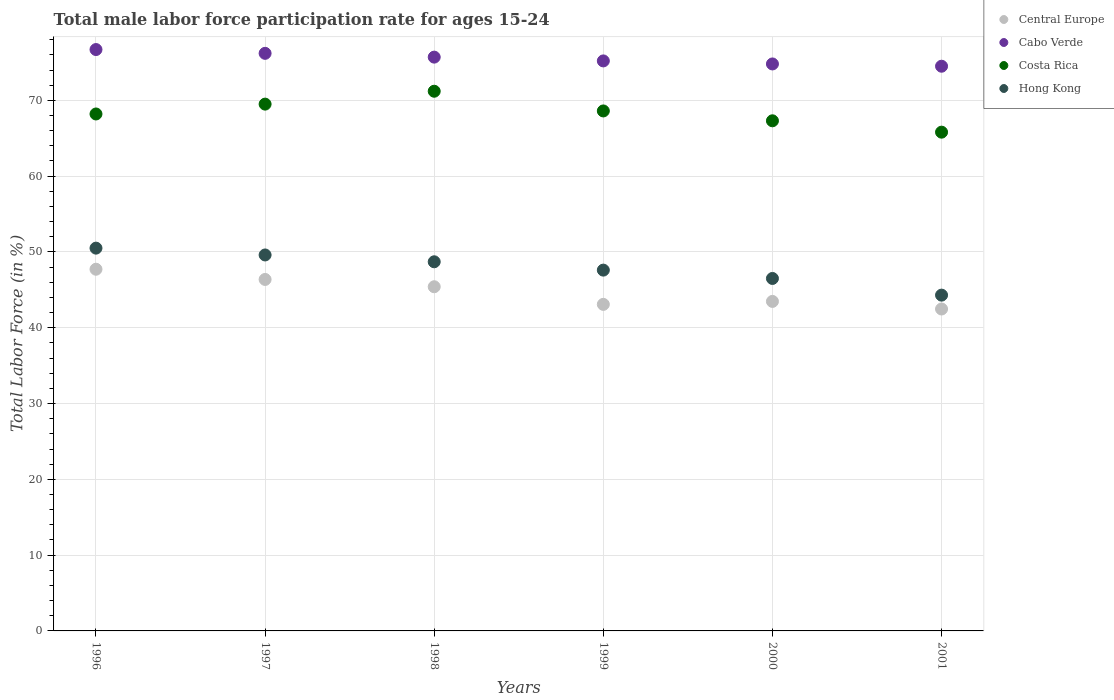Is the number of dotlines equal to the number of legend labels?
Provide a short and direct response. Yes. What is the male labor force participation rate in Central Europe in 2000?
Give a very brief answer. 43.47. Across all years, what is the maximum male labor force participation rate in Central Europe?
Keep it short and to the point. 47.72. Across all years, what is the minimum male labor force participation rate in Central Europe?
Keep it short and to the point. 42.47. In which year was the male labor force participation rate in Cabo Verde maximum?
Your answer should be compact. 1996. In which year was the male labor force participation rate in Central Europe minimum?
Your answer should be very brief. 2001. What is the total male labor force participation rate in Central Europe in the graph?
Your response must be concise. 268.52. What is the difference between the male labor force participation rate in Cabo Verde in 1997 and that in 2000?
Ensure brevity in your answer.  1.4. What is the average male labor force participation rate in Central Europe per year?
Your answer should be very brief. 44.75. In the year 1997, what is the difference between the male labor force participation rate in Central Europe and male labor force participation rate in Hong Kong?
Keep it short and to the point. -3.23. What is the ratio of the male labor force participation rate in Cabo Verde in 1998 to that in 2001?
Your answer should be very brief. 1.02. Is the male labor force participation rate in Central Europe in 2000 less than that in 2001?
Give a very brief answer. No. Is the difference between the male labor force participation rate in Central Europe in 1999 and 2000 greater than the difference between the male labor force participation rate in Hong Kong in 1999 and 2000?
Make the answer very short. No. What is the difference between the highest and the lowest male labor force participation rate in Central Europe?
Provide a short and direct response. 5.25. Is the sum of the male labor force participation rate in Central Europe in 1998 and 1999 greater than the maximum male labor force participation rate in Costa Rica across all years?
Your answer should be very brief. Yes. Is the male labor force participation rate in Cabo Verde strictly less than the male labor force participation rate in Costa Rica over the years?
Provide a short and direct response. No. How many dotlines are there?
Your answer should be very brief. 4. Does the graph contain any zero values?
Your response must be concise. No. How are the legend labels stacked?
Provide a short and direct response. Vertical. What is the title of the graph?
Give a very brief answer. Total male labor force participation rate for ages 15-24. What is the label or title of the X-axis?
Provide a succinct answer. Years. What is the Total Labor Force (in %) in Central Europe in 1996?
Your answer should be compact. 47.72. What is the Total Labor Force (in %) of Cabo Verde in 1996?
Provide a short and direct response. 76.7. What is the Total Labor Force (in %) of Costa Rica in 1996?
Your answer should be compact. 68.2. What is the Total Labor Force (in %) in Hong Kong in 1996?
Give a very brief answer. 50.5. What is the Total Labor Force (in %) of Central Europe in 1997?
Ensure brevity in your answer.  46.37. What is the Total Labor Force (in %) of Cabo Verde in 1997?
Your answer should be compact. 76.2. What is the Total Labor Force (in %) of Costa Rica in 1997?
Your response must be concise. 69.5. What is the Total Labor Force (in %) in Hong Kong in 1997?
Offer a very short reply. 49.6. What is the Total Labor Force (in %) in Central Europe in 1998?
Your answer should be very brief. 45.41. What is the Total Labor Force (in %) in Cabo Verde in 1998?
Provide a short and direct response. 75.7. What is the Total Labor Force (in %) in Costa Rica in 1998?
Keep it short and to the point. 71.2. What is the Total Labor Force (in %) of Hong Kong in 1998?
Your answer should be very brief. 48.7. What is the Total Labor Force (in %) of Central Europe in 1999?
Provide a short and direct response. 43.08. What is the Total Labor Force (in %) in Cabo Verde in 1999?
Keep it short and to the point. 75.2. What is the Total Labor Force (in %) of Costa Rica in 1999?
Your answer should be compact. 68.6. What is the Total Labor Force (in %) in Hong Kong in 1999?
Keep it short and to the point. 47.6. What is the Total Labor Force (in %) in Central Europe in 2000?
Offer a very short reply. 43.47. What is the Total Labor Force (in %) in Cabo Verde in 2000?
Your answer should be compact. 74.8. What is the Total Labor Force (in %) in Costa Rica in 2000?
Keep it short and to the point. 67.3. What is the Total Labor Force (in %) of Hong Kong in 2000?
Your answer should be compact. 46.5. What is the Total Labor Force (in %) of Central Europe in 2001?
Offer a very short reply. 42.47. What is the Total Labor Force (in %) in Cabo Verde in 2001?
Provide a short and direct response. 74.5. What is the Total Labor Force (in %) in Costa Rica in 2001?
Ensure brevity in your answer.  65.8. What is the Total Labor Force (in %) of Hong Kong in 2001?
Offer a terse response. 44.3. Across all years, what is the maximum Total Labor Force (in %) of Central Europe?
Offer a very short reply. 47.72. Across all years, what is the maximum Total Labor Force (in %) in Cabo Verde?
Make the answer very short. 76.7. Across all years, what is the maximum Total Labor Force (in %) in Costa Rica?
Keep it short and to the point. 71.2. Across all years, what is the maximum Total Labor Force (in %) of Hong Kong?
Provide a succinct answer. 50.5. Across all years, what is the minimum Total Labor Force (in %) in Central Europe?
Offer a very short reply. 42.47. Across all years, what is the minimum Total Labor Force (in %) of Cabo Verde?
Your answer should be very brief. 74.5. Across all years, what is the minimum Total Labor Force (in %) in Costa Rica?
Keep it short and to the point. 65.8. Across all years, what is the minimum Total Labor Force (in %) in Hong Kong?
Your answer should be compact. 44.3. What is the total Total Labor Force (in %) in Central Europe in the graph?
Your answer should be very brief. 268.52. What is the total Total Labor Force (in %) in Cabo Verde in the graph?
Give a very brief answer. 453.1. What is the total Total Labor Force (in %) in Costa Rica in the graph?
Make the answer very short. 410.6. What is the total Total Labor Force (in %) in Hong Kong in the graph?
Your answer should be compact. 287.2. What is the difference between the Total Labor Force (in %) in Central Europe in 1996 and that in 1997?
Your response must be concise. 1.35. What is the difference between the Total Labor Force (in %) of Cabo Verde in 1996 and that in 1997?
Give a very brief answer. 0.5. What is the difference between the Total Labor Force (in %) of Hong Kong in 1996 and that in 1997?
Provide a succinct answer. 0.9. What is the difference between the Total Labor Force (in %) in Central Europe in 1996 and that in 1998?
Your response must be concise. 2.31. What is the difference between the Total Labor Force (in %) of Costa Rica in 1996 and that in 1998?
Your response must be concise. -3. What is the difference between the Total Labor Force (in %) in Hong Kong in 1996 and that in 1998?
Your answer should be compact. 1.8. What is the difference between the Total Labor Force (in %) in Central Europe in 1996 and that in 1999?
Give a very brief answer. 4.64. What is the difference between the Total Labor Force (in %) of Cabo Verde in 1996 and that in 1999?
Make the answer very short. 1.5. What is the difference between the Total Labor Force (in %) in Costa Rica in 1996 and that in 1999?
Keep it short and to the point. -0.4. What is the difference between the Total Labor Force (in %) in Central Europe in 1996 and that in 2000?
Your answer should be very brief. 4.25. What is the difference between the Total Labor Force (in %) in Costa Rica in 1996 and that in 2000?
Offer a very short reply. 0.9. What is the difference between the Total Labor Force (in %) in Central Europe in 1996 and that in 2001?
Your answer should be compact. 5.25. What is the difference between the Total Labor Force (in %) of Cabo Verde in 1996 and that in 2001?
Provide a succinct answer. 2.2. What is the difference between the Total Labor Force (in %) in Hong Kong in 1996 and that in 2001?
Provide a succinct answer. 6.2. What is the difference between the Total Labor Force (in %) in Central Europe in 1997 and that in 1998?
Your response must be concise. 0.96. What is the difference between the Total Labor Force (in %) in Costa Rica in 1997 and that in 1998?
Ensure brevity in your answer.  -1.7. What is the difference between the Total Labor Force (in %) in Central Europe in 1997 and that in 1999?
Keep it short and to the point. 3.29. What is the difference between the Total Labor Force (in %) of Costa Rica in 1997 and that in 1999?
Ensure brevity in your answer.  0.9. What is the difference between the Total Labor Force (in %) of Central Europe in 1997 and that in 2000?
Ensure brevity in your answer.  2.9. What is the difference between the Total Labor Force (in %) of Central Europe in 1997 and that in 2001?
Keep it short and to the point. 3.9. What is the difference between the Total Labor Force (in %) in Cabo Verde in 1997 and that in 2001?
Provide a short and direct response. 1.7. What is the difference between the Total Labor Force (in %) of Costa Rica in 1997 and that in 2001?
Your response must be concise. 3.7. What is the difference between the Total Labor Force (in %) in Central Europe in 1998 and that in 1999?
Make the answer very short. 2.32. What is the difference between the Total Labor Force (in %) of Cabo Verde in 1998 and that in 1999?
Offer a terse response. 0.5. What is the difference between the Total Labor Force (in %) of Hong Kong in 1998 and that in 1999?
Your response must be concise. 1.1. What is the difference between the Total Labor Force (in %) of Central Europe in 1998 and that in 2000?
Offer a very short reply. 1.93. What is the difference between the Total Labor Force (in %) in Cabo Verde in 1998 and that in 2000?
Provide a succinct answer. 0.9. What is the difference between the Total Labor Force (in %) in Costa Rica in 1998 and that in 2000?
Ensure brevity in your answer.  3.9. What is the difference between the Total Labor Force (in %) of Hong Kong in 1998 and that in 2000?
Give a very brief answer. 2.2. What is the difference between the Total Labor Force (in %) of Central Europe in 1998 and that in 2001?
Offer a very short reply. 2.94. What is the difference between the Total Labor Force (in %) in Costa Rica in 1998 and that in 2001?
Your answer should be very brief. 5.4. What is the difference between the Total Labor Force (in %) in Central Europe in 1999 and that in 2000?
Offer a very short reply. -0.39. What is the difference between the Total Labor Force (in %) of Central Europe in 1999 and that in 2001?
Keep it short and to the point. 0.61. What is the difference between the Total Labor Force (in %) of Cabo Verde in 1999 and that in 2001?
Keep it short and to the point. 0.7. What is the difference between the Total Labor Force (in %) in Costa Rica in 1999 and that in 2001?
Ensure brevity in your answer.  2.8. What is the difference between the Total Labor Force (in %) in Central Europe in 2000 and that in 2001?
Keep it short and to the point. 1. What is the difference between the Total Labor Force (in %) in Cabo Verde in 2000 and that in 2001?
Offer a terse response. 0.3. What is the difference between the Total Labor Force (in %) in Hong Kong in 2000 and that in 2001?
Your answer should be very brief. 2.2. What is the difference between the Total Labor Force (in %) in Central Europe in 1996 and the Total Labor Force (in %) in Cabo Verde in 1997?
Your answer should be very brief. -28.48. What is the difference between the Total Labor Force (in %) in Central Europe in 1996 and the Total Labor Force (in %) in Costa Rica in 1997?
Your answer should be compact. -21.78. What is the difference between the Total Labor Force (in %) of Central Europe in 1996 and the Total Labor Force (in %) of Hong Kong in 1997?
Provide a short and direct response. -1.88. What is the difference between the Total Labor Force (in %) of Cabo Verde in 1996 and the Total Labor Force (in %) of Hong Kong in 1997?
Offer a terse response. 27.1. What is the difference between the Total Labor Force (in %) of Central Europe in 1996 and the Total Labor Force (in %) of Cabo Verde in 1998?
Your answer should be compact. -27.98. What is the difference between the Total Labor Force (in %) in Central Europe in 1996 and the Total Labor Force (in %) in Costa Rica in 1998?
Offer a very short reply. -23.48. What is the difference between the Total Labor Force (in %) of Central Europe in 1996 and the Total Labor Force (in %) of Hong Kong in 1998?
Provide a short and direct response. -0.98. What is the difference between the Total Labor Force (in %) of Cabo Verde in 1996 and the Total Labor Force (in %) of Costa Rica in 1998?
Your answer should be very brief. 5.5. What is the difference between the Total Labor Force (in %) of Cabo Verde in 1996 and the Total Labor Force (in %) of Hong Kong in 1998?
Keep it short and to the point. 28. What is the difference between the Total Labor Force (in %) of Costa Rica in 1996 and the Total Labor Force (in %) of Hong Kong in 1998?
Keep it short and to the point. 19.5. What is the difference between the Total Labor Force (in %) of Central Europe in 1996 and the Total Labor Force (in %) of Cabo Verde in 1999?
Make the answer very short. -27.48. What is the difference between the Total Labor Force (in %) of Central Europe in 1996 and the Total Labor Force (in %) of Costa Rica in 1999?
Your answer should be very brief. -20.88. What is the difference between the Total Labor Force (in %) of Central Europe in 1996 and the Total Labor Force (in %) of Hong Kong in 1999?
Offer a terse response. 0.12. What is the difference between the Total Labor Force (in %) of Cabo Verde in 1996 and the Total Labor Force (in %) of Hong Kong in 1999?
Ensure brevity in your answer.  29.1. What is the difference between the Total Labor Force (in %) in Costa Rica in 1996 and the Total Labor Force (in %) in Hong Kong in 1999?
Your answer should be compact. 20.6. What is the difference between the Total Labor Force (in %) of Central Europe in 1996 and the Total Labor Force (in %) of Cabo Verde in 2000?
Provide a succinct answer. -27.08. What is the difference between the Total Labor Force (in %) in Central Europe in 1996 and the Total Labor Force (in %) in Costa Rica in 2000?
Keep it short and to the point. -19.58. What is the difference between the Total Labor Force (in %) of Central Europe in 1996 and the Total Labor Force (in %) of Hong Kong in 2000?
Offer a very short reply. 1.22. What is the difference between the Total Labor Force (in %) in Cabo Verde in 1996 and the Total Labor Force (in %) in Costa Rica in 2000?
Give a very brief answer. 9.4. What is the difference between the Total Labor Force (in %) in Cabo Verde in 1996 and the Total Labor Force (in %) in Hong Kong in 2000?
Offer a terse response. 30.2. What is the difference between the Total Labor Force (in %) in Costa Rica in 1996 and the Total Labor Force (in %) in Hong Kong in 2000?
Make the answer very short. 21.7. What is the difference between the Total Labor Force (in %) in Central Europe in 1996 and the Total Labor Force (in %) in Cabo Verde in 2001?
Your answer should be compact. -26.78. What is the difference between the Total Labor Force (in %) in Central Europe in 1996 and the Total Labor Force (in %) in Costa Rica in 2001?
Keep it short and to the point. -18.08. What is the difference between the Total Labor Force (in %) in Central Europe in 1996 and the Total Labor Force (in %) in Hong Kong in 2001?
Provide a short and direct response. 3.42. What is the difference between the Total Labor Force (in %) in Cabo Verde in 1996 and the Total Labor Force (in %) in Hong Kong in 2001?
Provide a short and direct response. 32.4. What is the difference between the Total Labor Force (in %) of Costa Rica in 1996 and the Total Labor Force (in %) of Hong Kong in 2001?
Your response must be concise. 23.9. What is the difference between the Total Labor Force (in %) in Central Europe in 1997 and the Total Labor Force (in %) in Cabo Verde in 1998?
Offer a terse response. -29.33. What is the difference between the Total Labor Force (in %) in Central Europe in 1997 and the Total Labor Force (in %) in Costa Rica in 1998?
Keep it short and to the point. -24.83. What is the difference between the Total Labor Force (in %) of Central Europe in 1997 and the Total Labor Force (in %) of Hong Kong in 1998?
Offer a very short reply. -2.33. What is the difference between the Total Labor Force (in %) of Cabo Verde in 1997 and the Total Labor Force (in %) of Costa Rica in 1998?
Offer a terse response. 5. What is the difference between the Total Labor Force (in %) in Costa Rica in 1997 and the Total Labor Force (in %) in Hong Kong in 1998?
Your answer should be compact. 20.8. What is the difference between the Total Labor Force (in %) of Central Europe in 1997 and the Total Labor Force (in %) of Cabo Verde in 1999?
Give a very brief answer. -28.83. What is the difference between the Total Labor Force (in %) in Central Europe in 1997 and the Total Labor Force (in %) in Costa Rica in 1999?
Your response must be concise. -22.23. What is the difference between the Total Labor Force (in %) of Central Europe in 1997 and the Total Labor Force (in %) of Hong Kong in 1999?
Offer a terse response. -1.23. What is the difference between the Total Labor Force (in %) in Cabo Verde in 1997 and the Total Labor Force (in %) in Costa Rica in 1999?
Make the answer very short. 7.6. What is the difference between the Total Labor Force (in %) in Cabo Verde in 1997 and the Total Labor Force (in %) in Hong Kong in 1999?
Offer a terse response. 28.6. What is the difference between the Total Labor Force (in %) of Costa Rica in 1997 and the Total Labor Force (in %) of Hong Kong in 1999?
Give a very brief answer. 21.9. What is the difference between the Total Labor Force (in %) in Central Europe in 1997 and the Total Labor Force (in %) in Cabo Verde in 2000?
Provide a short and direct response. -28.43. What is the difference between the Total Labor Force (in %) in Central Europe in 1997 and the Total Labor Force (in %) in Costa Rica in 2000?
Provide a short and direct response. -20.93. What is the difference between the Total Labor Force (in %) of Central Europe in 1997 and the Total Labor Force (in %) of Hong Kong in 2000?
Provide a short and direct response. -0.13. What is the difference between the Total Labor Force (in %) of Cabo Verde in 1997 and the Total Labor Force (in %) of Costa Rica in 2000?
Ensure brevity in your answer.  8.9. What is the difference between the Total Labor Force (in %) in Cabo Verde in 1997 and the Total Labor Force (in %) in Hong Kong in 2000?
Your answer should be very brief. 29.7. What is the difference between the Total Labor Force (in %) of Costa Rica in 1997 and the Total Labor Force (in %) of Hong Kong in 2000?
Offer a very short reply. 23. What is the difference between the Total Labor Force (in %) of Central Europe in 1997 and the Total Labor Force (in %) of Cabo Verde in 2001?
Ensure brevity in your answer.  -28.13. What is the difference between the Total Labor Force (in %) in Central Europe in 1997 and the Total Labor Force (in %) in Costa Rica in 2001?
Provide a short and direct response. -19.43. What is the difference between the Total Labor Force (in %) of Central Europe in 1997 and the Total Labor Force (in %) of Hong Kong in 2001?
Keep it short and to the point. 2.07. What is the difference between the Total Labor Force (in %) of Cabo Verde in 1997 and the Total Labor Force (in %) of Hong Kong in 2001?
Your answer should be compact. 31.9. What is the difference between the Total Labor Force (in %) of Costa Rica in 1997 and the Total Labor Force (in %) of Hong Kong in 2001?
Provide a short and direct response. 25.2. What is the difference between the Total Labor Force (in %) of Central Europe in 1998 and the Total Labor Force (in %) of Cabo Verde in 1999?
Your answer should be compact. -29.79. What is the difference between the Total Labor Force (in %) of Central Europe in 1998 and the Total Labor Force (in %) of Costa Rica in 1999?
Offer a terse response. -23.19. What is the difference between the Total Labor Force (in %) of Central Europe in 1998 and the Total Labor Force (in %) of Hong Kong in 1999?
Your response must be concise. -2.19. What is the difference between the Total Labor Force (in %) in Cabo Verde in 1998 and the Total Labor Force (in %) in Costa Rica in 1999?
Provide a short and direct response. 7.1. What is the difference between the Total Labor Force (in %) in Cabo Verde in 1998 and the Total Labor Force (in %) in Hong Kong in 1999?
Your answer should be compact. 28.1. What is the difference between the Total Labor Force (in %) of Costa Rica in 1998 and the Total Labor Force (in %) of Hong Kong in 1999?
Ensure brevity in your answer.  23.6. What is the difference between the Total Labor Force (in %) of Central Europe in 1998 and the Total Labor Force (in %) of Cabo Verde in 2000?
Give a very brief answer. -29.39. What is the difference between the Total Labor Force (in %) of Central Europe in 1998 and the Total Labor Force (in %) of Costa Rica in 2000?
Offer a very short reply. -21.89. What is the difference between the Total Labor Force (in %) in Central Europe in 1998 and the Total Labor Force (in %) in Hong Kong in 2000?
Your answer should be compact. -1.09. What is the difference between the Total Labor Force (in %) in Cabo Verde in 1998 and the Total Labor Force (in %) in Hong Kong in 2000?
Give a very brief answer. 29.2. What is the difference between the Total Labor Force (in %) in Costa Rica in 1998 and the Total Labor Force (in %) in Hong Kong in 2000?
Offer a very short reply. 24.7. What is the difference between the Total Labor Force (in %) in Central Europe in 1998 and the Total Labor Force (in %) in Cabo Verde in 2001?
Give a very brief answer. -29.09. What is the difference between the Total Labor Force (in %) in Central Europe in 1998 and the Total Labor Force (in %) in Costa Rica in 2001?
Give a very brief answer. -20.39. What is the difference between the Total Labor Force (in %) in Central Europe in 1998 and the Total Labor Force (in %) in Hong Kong in 2001?
Your answer should be very brief. 1.11. What is the difference between the Total Labor Force (in %) in Cabo Verde in 1998 and the Total Labor Force (in %) in Hong Kong in 2001?
Make the answer very short. 31.4. What is the difference between the Total Labor Force (in %) of Costa Rica in 1998 and the Total Labor Force (in %) of Hong Kong in 2001?
Ensure brevity in your answer.  26.9. What is the difference between the Total Labor Force (in %) of Central Europe in 1999 and the Total Labor Force (in %) of Cabo Verde in 2000?
Offer a terse response. -31.72. What is the difference between the Total Labor Force (in %) in Central Europe in 1999 and the Total Labor Force (in %) in Costa Rica in 2000?
Provide a short and direct response. -24.22. What is the difference between the Total Labor Force (in %) in Central Europe in 1999 and the Total Labor Force (in %) in Hong Kong in 2000?
Ensure brevity in your answer.  -3.42. What is the difference between the Total Labor Force (in %) of Cabo Verde in 1999 and the Total Labor Force (in %) of Hong Kong in 2000?
Make the answer very short. 28.7. What is the difference between the Total Labor Force (in %) in Costa Rica in 1999 and the Total Labor Force (in %) in Hong Kong in 2000?
Keep it short and to the point. 22.1. What is the difference between the Total Labor Force (in %) of Central Europe in 1999 and the Total Labor Force (in %) of Cabo Verde in 2001?
Offer a very short reply. -31.42. What is the difference between the Total Labor Force (in %) of Central Europe in 1999 and the Total Labor Force (in %) of Costa Rica in 2001?
Provide a succinct answer. -22.72. What is the difference between the Total Labor Force (in %) of Central Europe in 1999 and the Total Labor Force (in %) of Hong Kong in 2001?
Offer a very short reply. -1.22. What is the difference between the Total Labor Force (in %) of Cabo Verde in 1999 and the Total Labor Force (in %) of Costa Rica in 2001?
Your answer should be compact. 9.4. What is the difference between the Total Labor Force (in %) of Cabo Verde in 1999 and the Total Labor Force (in %) of Hong Kong in 2001?
Keep it short and to the point. 30.9. What is the difference between the Total Labor Force (in %) of Costa Rica in 1999 and the Total Labor Force (in %) of Hong Kong in 2001?
Your answer should be compact. 24.3. What is the difference between the Total Labor Force (in %) in Central Europe in 2000 and the Total Labor Force (in %) in Cabo Verde in 2001?
Offer a terse response. -31.03. What is the difference between the Total Labor Force (in %) of Central Europe in 2000 and the Total Labor Force (in %) of Costa Rica in 2001?
Keep it short and to the point. -22.33. What is the difference between the Total Labor Force (in %) of Central Europe in 2000 and the Total Labor Force (in %) of Hong Kong in 2001?
Offer a terse response. -0.83. What is the difference between the Total Labor Force (in %) of Cabo Verde in 2000 and the Total Labor Force (in %) of Hong Kong in 2001?
Make the answer very short. 30.5. What is the difference between the Total Labor Force (in %) in Costa Rica in 2000 and the Total Labor Force (in %) in Hong Kong in 2001?
Provide a succinct answer. 23. What is the average Total Labor Force (in %) of Central Europe per year?
Provide a succinct answer. 44.75. What is the average Total Labor Force (in %) in Cabo Verde per year?
Give a very brief answer. 75.52. What is the average Total Labor Force (in %) of Costa Rica per year?
Keep it short and to the point. 68.43. What is the average Total Labor Force (in %) of Hong Kong per year?
Offer a very short reply. 47.87. In the year 1996, what is the difference between the Total Labor Force (in %) of Central Europe and Total Labor Force (in %) of Cabo Verde?
Ensure brevity in your answer.  -28.98. In the year 1996, what is the difference between the Total Labor Force (in %) in Central Europe and Total Labor Force (in %) in Costa Rica?
Ensure brevity in your answer.  -20.48. In the year 1996, what is the difference between the Total Labor Force (in %) of Central Europe and Total Labor Force (in %) of Hong Kong?
Your answer should be very brief. -2.78. In the year 1996, what is the difference between the Total Labor Force (in %) of Cabo Verde and Total Labor Force (in %) of Costa Rica?
Provide a short and direct response. 8.5. In the year 1996, what is the difference between the Total Labor Force (in %) of Cabo Verde and Total Labor Force (in %) of Hong Kong?
Keep it short and to the point. 26.2. In the year 1996, what is the difference between the Total Labor Force (in %) in Costa Rica and Total Labor Force (in %) in Hong Kong?
Provide a succinct answer. 17.7. In the year 1997, what is the difference between the Total Labor Force (in %) of Central Europe and Total Labor Force (in %) of Cabo Verde?
Make the answer very short. -29.83. In the year 1997, what is the difference between the Total Labor Force (in %) in Central Europe and Total Labor Force (in %) in Costa Rica?
Ensure brevity in your answer.  -23.13. In the year 1997, what is the difference between the Total Labor Force (in %) in Central Europe and Total Labor Force (in %) in Hong Kong?
Your answer should be very brief. -3.23. In the year 1997, what is the difference between the Total Labor Force (in %) of Cabo Verde and Total Labor Force (in %) of Hong Kong?
Your answer should be very brief. 26.6. In the year 1998, what is the difference between the Total Labor Force (in %) of Central Europe and Total Labor Force (in %) of Cabo Verde?
Keep it short and to the point. -30.29. In the year 1998, what is the difference between the Total Labor Force (in %) in Central Europe and Total Labor Force (in %) in Costa Rica?
Keep it short and to the point. -25.79. In the year 1998, what is the difference between the Total Labor Force (in %) in Central Europe and Total Labor Force (in %) in Hong Kong?
Ensure brevity in your answer.  -3.29. In the year 1998, what is the difference between the Total Labor Force (in %) of Cabo Verde and Total Labor Force (in %) of Costa Rica?
Provide a short and direct response. 4.5. In the year 1998, what is the difference between the Total Labor Force (in %) in Cabo Verde and Total Labor Force (in %) in Hong Kong?
Your response must be concise. 27. In the year 1998, what is the difference between the Total Labor Force (in %) of Costa Rica and Total Labor Force (in %) of Hong Kong?
Your answer should be very brief. 22.5. In the year 1999, what is the difference between the Total Labor Force (in %) in Central Europe and Total Labor Force (in %) in Cabo Verde?
Offer a very short reply. -32.12. In the year 1999, what is the difference between the Total Labor Force (in %) of Central Europe and Total Labor Force (in %) of Costa Rica?
Your answer should be compact. -25.52. In the year 1999, what is the difference between the Total Labor Force (in %) in Central Europe and Total Labor Force (in %) in Hong Kong?
Offer a terse response. -4.52. In the year 1999, what is the difference between the Total Labor Force (in %) in Cabo Verde and Total Labor Force (in %) in Hong Kong?
Ensure brevity in your answer.  27.6. In the year 1999, what is the difference between the Total Labor Force (in %) in Costa Rica and Total Labor Force (in %) in Hong Kong?
Your answer should be compact. 21. In the year 2000, what is the difference between the Total Labor Force (in %) of Central Europe and Total Labor Force (in %) of Cabo Verde?
Give a very brief answer. -31.33. In the year 2000, what is the difference between the Total Labor Force (in %) in Central Europe and Total Labor Force (in %) in Costa Rica?
Provide a short and direct response. -23.83. In the year 2000, what is the difference between the Total Labor Force (in %) of Central Europe and Total Labor Force (in %) of Hong Kong?
Ensure brevity in your answer.  -3.03. In the year 2000, what is the difference between the Total Labor Force (in %) of Cabo Verde and Total Labor Force (in %) of Costa Rica?
Your answer should be very brief. 7.5. In the year 2000, what is the difference between the Total Labor Force (in %) of Cabo Verde and Total Labor Force (in %) of Hong Kong?
Your response must be concise. 28.3. In the year 2000, what is the difference between the Total Labor Force (in %) of Costa Rica and Total Labor Force (in %) of Hong Kong?
Your answer should be compact. 20.8. In the year 2001, what is the difference between the Total Labor Force (in %) in Central Europe and Total Labor Force (in %) in Cabo Verde?
Keep it short and to the point. -32.03. In the year 2001, what is the difference between the Total Labor Force (in %) of Central Europe and Total Labor Force (in %) of Costa Rica?
Provide a short and direct response. -23.33. In the year 2001, what is the difference between the Total Labor Force (in %) in Central Europe and Total Labor Force (in %) in Hong Kong?
Make the answer very short. -1.83. In the year 2001, what is the difference between the Total Labor Force (in %) of Cabo Verde and Total Labor Force (in %) of Hong Kong?
Make the answer very short. 30.2. In the year 2001, what is the difference between the Total Labor Force (in %) of Costa Rica and Total Labor Force (in %) of Hong Kong?
Your answer should be very brief. 21.5. What is the ratio of the Total Labor Force (in %) of Central Europe in 1996 to that in 1997?
Give a very brief answer. 1.03. What is the ratio of the Total Labor Force (in %) of Cabo Verde in 1996 to that in 1997?
Give a very brief answer. 1.01. What is the ratio of the Total Labor Force (in %) of Costa Rica in 1996 to that in 1997?
Your answer should be very brief. 0.98. What is the ratio of the Total Labor Force (in %) in Hong Kong in 1996 to that in 1997?
Provide a short and direct response. 1.02. What is the ratio of the Total Labor Force (in %) in Central Europe in 1996 to that in 1998?
Offer a terse response. 1.05. What is the ratio of the Total Labor Force (in %) in Cabo Verde in 1996 to that in 1998?
Give a very brief answer. 1.01. What is the ratio of the Total Labor Force (in %) in Costa Rica in 1996 to that in 1998?
Your answer should be compact. 0.96. What is the ratio of the Total Labor Force (in %) in Central Europe in 1996 to that in 1999?
Offer a very short reply. 1.11. What is the ratio of the Total Labor Force (in %) of Cabo Verde in 1996 to that in 1999?
Offer a terse response. 1.02. What is the ratio of the Total Labor Force (in %) of Costa Rica in 1996 to that in 1999?
Your response must be concise. 0.99. What is the ratio of the Total Labor Force (in %) of Hong Kong in 1996 to that in 1999?
Provide a short and direct response. 1.06. What is the ratio of the Total Labor Force (in %) of Central Europe in 1996 to that in 2000?
Your answer should be compact. 1.1. What is the ratio of the Total Labor Force (in %) of Cabo Verde in 1996 to that in 2000?
Keep it short and to the point. 1.03. What is the ratio of the Total Labor Force (in %) in Costa Rica in 1996 to that in 2000?
Provide a succinct answer. 1.01. What is the ratio of the Total Labor Force (in %) of Hong Kong in 1996 to that in 2000?
Ensure brevity in your answer.  1.09. What is the ratio of the Total Labor Force (in %) in Central Europe in 1996 to that in 2001?
Provide a succinct answer. 1.12. What is the ratio of the Total Labor Force (in %) of Cabo Verde in 1996 to that in 2001?
Provide a short and direct response. 1.03. What is the ratio of the Total Labor Force (in %) in Costa Rica in 1996 to that in 2001?
Provide a short and direct response. 1.04. What is the ratio of the Total Labor Force (in %) of Hong Kong in 1996 to that in 2001?
Your response must be concise. 1.14. What is the ratio of the Total Labor Force (in %) in Central Europe in 1997 to that in 1998?
Ensure brevity in your answer.  1.02. What is the ratio of the Total Labor Force (in %) in Cabo Verde in 1997 to that in 1998?
Provide a short and direct response. 1.01. What is the ratio of the Total Labor Force (in %) in Costa Rica in 1997 to that in 1998?
Your response must be concise. 0.98. What is the ratio of the Total Labor Force (in %) of Hong Kong in 1997 to that in 1998?
Give a very brief answer. 1.02. What is the ratio of the Total Labor Force (in %) of Central Europe in 1997 to that in 1999?
Offer a very short reply. 1.08. What is the ratio of the Total Labor Force (in %) of Cabo Verde in 1997 to that in 1999?
Offer a very short reply. 1.01. What is the ratio of the Total Labor Force (in %) in Costa Rica in 1997 to that in 1999?
Your answer should be compact. 1.01. What is the ratio of the Total Labor Force (in %) in Hong Kong in 1997 to that in 1999?
Provide a short and direct response. 1.04. What is the ratio of the Total Labor Force (in %) in Central Europe in 1997 to that in 2000?
Your answer should be compact. 1.07. What is the ratio of the Total Labor Force (in %) of Cabo Verde in 1997 to that in 2000?
Keep it short and to the point. 1.02. What is the ratio of the Total Labor Force (in %) in Costa Rica in 1997 to that in 2000?
Keep it short and to the point. 1.03. What is the ratio of the Total Labor Force (in %) of Hong Kong in 1997 to that in 2000?
Your response must be concise. 1.07. What is the ratio of the Total Labor Force (in %) in Central Europe in 1997 to that in 2001?
Give a very brief answer. 1.09. What is the ratio of the Total Labor Force (in %) of Cabo Verde in 1997 to that in 2001?
Offer a terse response. 1.02. What is the ratio of the Total Labor Force (in %) in Costa Rica in 1997 to that in 2001?
Give a very brief answer. 1.06. What is the ratio of the Total Labor Force (in %) in Hong Kong in 1997 to that in 2001?
Give a very brief answer. 1.12. What is the ratio of the Total Labor Force (in %) of Central Europe in 1998 to that in 1999?
Ensure brevity in your answer.  1.05. What is the ratio of the Total Labor Force (in %) of Cabo Verde in 1998 to that in 1999?
Provide a succinct answer. 1.01. What is the ratio of the Total Labor Force (in %) of Costa Rica in 1998 to that in 1999?
Provide a succinct answer. 1.04. What is the ratio of the Total Labor Force (in %) in Hong Kong in 1998 to that in 1999?
Offer a terse response. 1.02. What is the ratio of the Total Labor Force (in %) in Central Europe in 1998 to that in 2000?
Provide a short and direct response. 1.04. What is the ratio of the Total Labor Force (in %) of Costa Rica in 1998 to that in 2000?
Your response must be concise. 1.06. What is the ratio of the Total Labor Force (in %) of Hong Kong in 1998 to that in 2000?
Your response must be concise. 1.05. What is the ratio of the Total Labor Force (in %) of Central Europe in 1998 to that in 2001?
Ensure brevity in your answer.  1.07. What is the ratio of the Total Labor Force (in %) in Cabo Verde in 1998 to that in 2001?
Your answer should be compact. 1.02. What is the ratio of the Total Labor Force (in %) in Costa Rica in 1998 to that in 2001?
Offer a very short reply. 1.08. What is the ratio of the Total Labor Force (in %) in Hong Kong in 1998 to that in 2001?
Give a very brief answer. 1.1. What is the ratio of the Total Labor Force (in %) of Costa Rica in 1999 to that in 2000?
Your answer should be compact. 1.02. What is the ratio of the Total Labor Force (in %) of Hong Kong in 1999 to that in 2000?
Make the answer very short. 1.02. What is the ratio of the Total Labor Force (in %) in Central Europe in 1999 to that in 2001?
Provide a succinct answer. 1.01. What is the ratio of the Total Labor Force (in %) in Cabo Verde in 1999 to that in 2001?
Keep it short and to the point. 1.01. What is the ratio of the Total Labor Force (in %) of Costa Rica in 1999 to that in 2001?
Keep it short and to the point. 1.04. What is the ratio of the Total Labor Force (in %) in Hong Kong in 1999 to that in 2001?
Provide a short and direct response. 1.07. What is the ratio of the Total Labor Force (in %) in Central Europe in 2000 to that in 2001?
Keep it short and to the point. 1.02. What is the ratio of the Total Labor Force (in %) in Costa Rica in 2000 to that in 2001?
Offer a very short reply. 1.02. What is the ratio of the Total Labor Force (in %) in Hong Kong in 2000 to that in 2001?
Ensure brevity in your answer.  1.05. What is the difference between the highest and the second highest Total Labor Force (in %) in Central Europe?
Your response must be concise. 1.35. What is the difference between the highest and the second highest Total Labor Force (in %) of Costa Rica?
Provide a short and direct response. 1.7. What is the difference between the highest and the second highest Total Labor Force (in %) in Hong Kong?
Keep it short and to the point. 0.9. What is the difference between the highest and the lowest Total Labor Force (in %) in Central Europe?
Your response must be concise. 5.25. What is the difference between the highest and the lowest Total Labor Force (in %) in Costa Rica?
Your response must be concise. 5.4. 